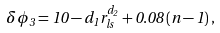Convert formula to latex. <formula><loc_0><loc_0><loc_500><loc_500>\delta \phi _ { 3 } = 1 0 - d _ { 1 } r _ { l s } ^ { d _ { 2 } } + 0 . 0 8 \, ( n - 1 ) \, ,</formula> 